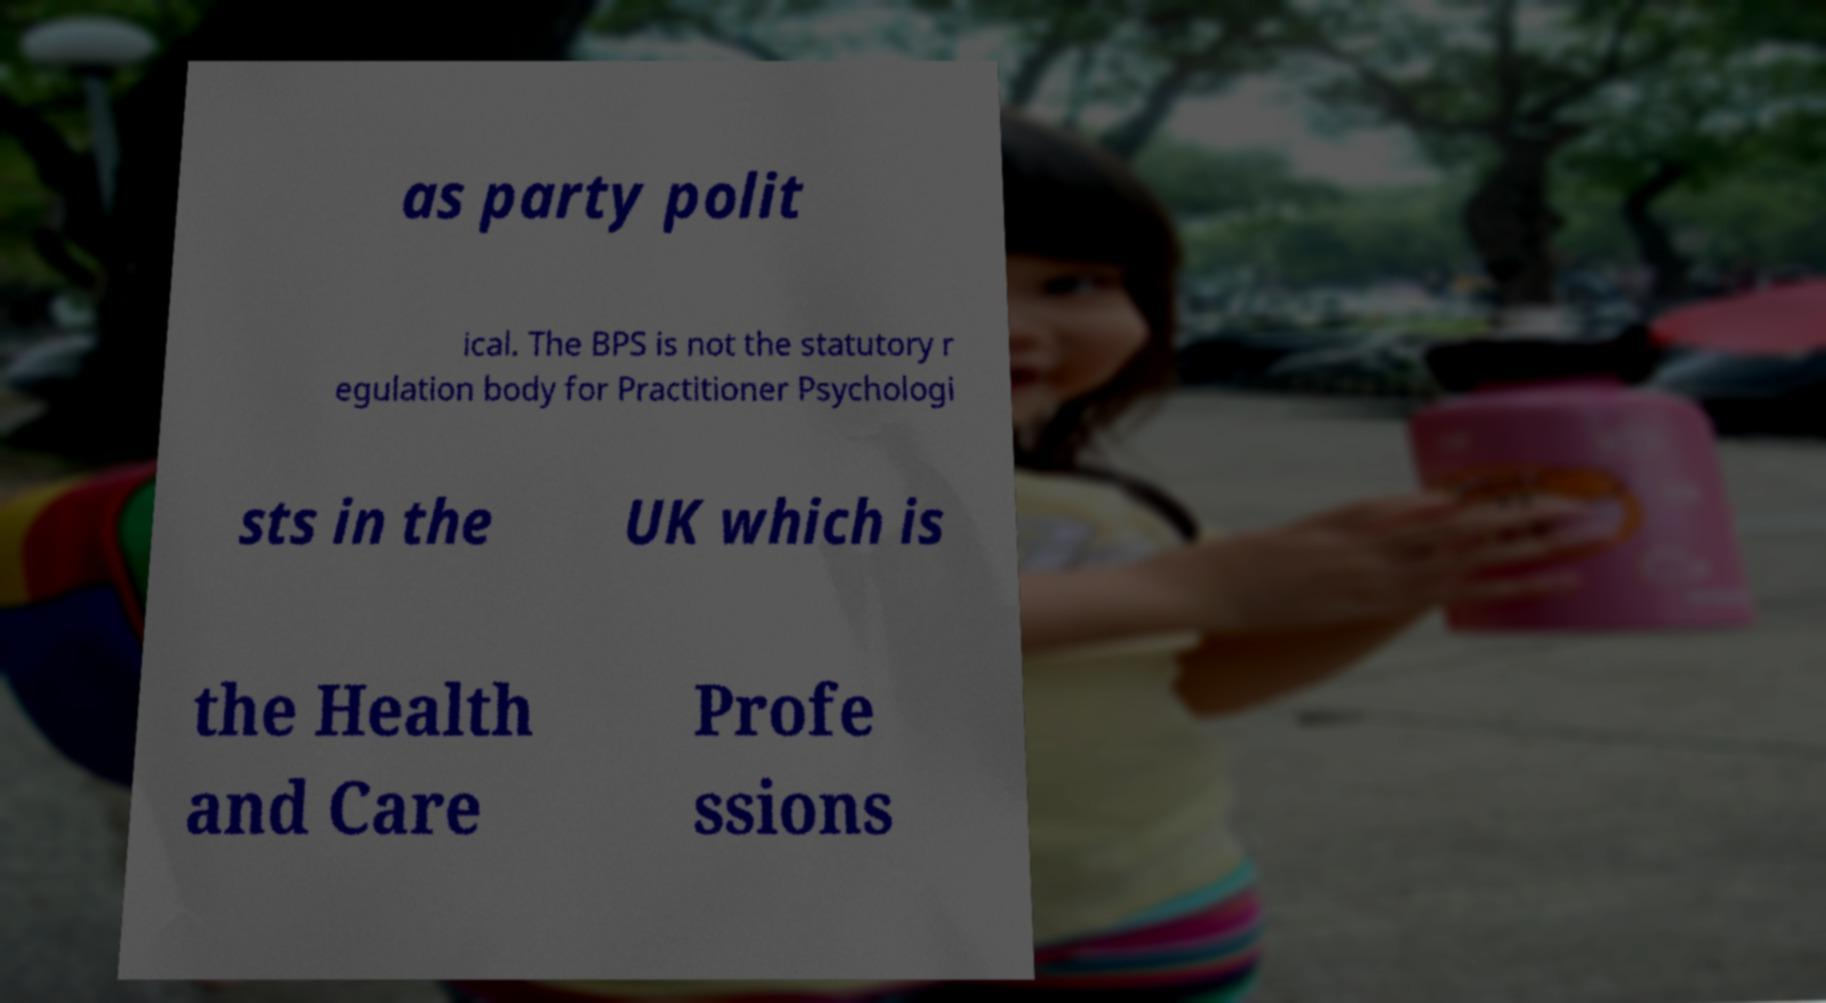For documentation purposes, I need the text within this image transcribed. Could you provide that? as party polit ical. The BPS is not the statutory r egulation body for Practitioner Psychologi sts in the UK which is the Health and Care Profe ssions 